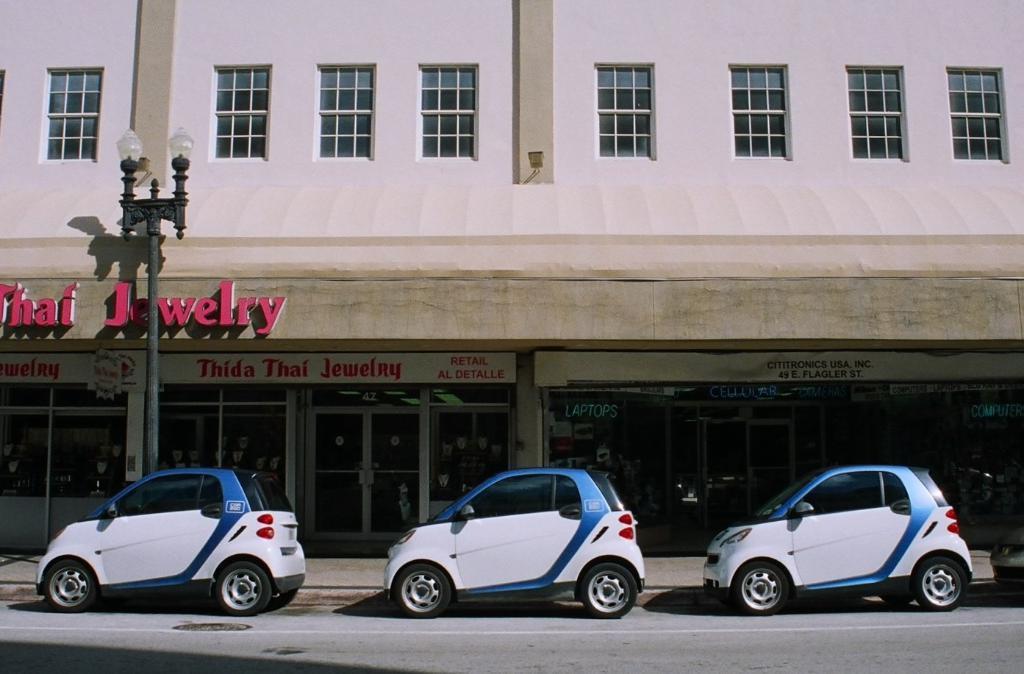In one or two sentences, can you explain what this image depicts? In this picture I can see vehicles on the road, there is a building, there are boards, lights and a pole. 